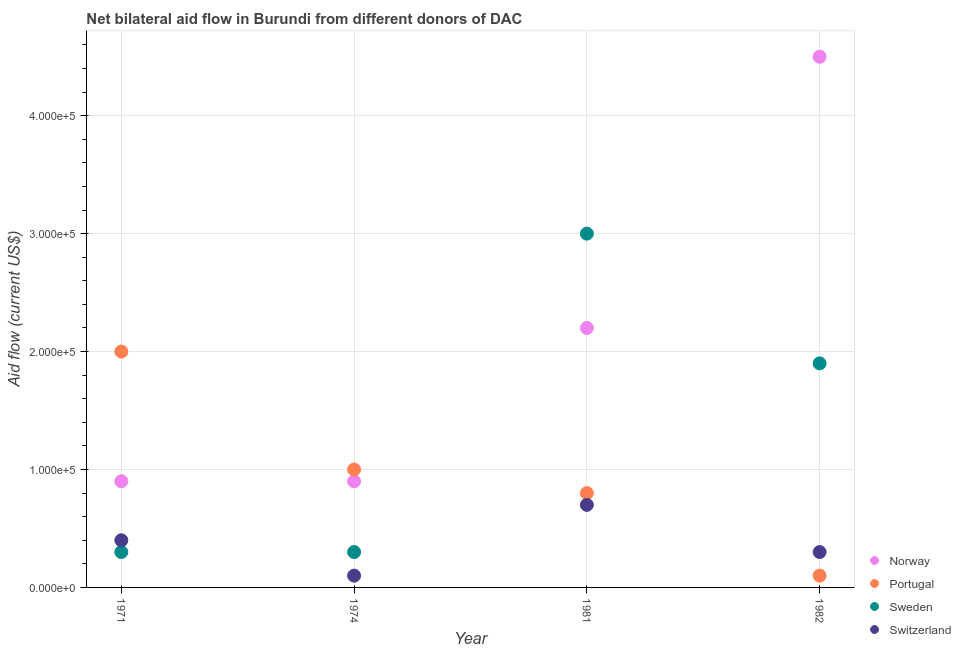How many different coloured dotlines are there?
Your answer should be compact. 4. Is the number of dotlines equal to the number of legend labels?
Offer a very short reply. Yes. What is the amount of aid given by switzerland in 1974?
Ensure brevity in your answer.  10000. Across all years, what is the maximum amount of aid given by sweden?
Make the answer very short. 3.00e+05. Across all years, what is the minimum amount of aid given by norway?
Your response must be concise. 9.00e+04. In which year was the amount of aid given by norway maximum?
Your answer should be compact. 1982. In which year was the amount of aid given by switzerland minimum?
Provide a succinct answer. 1974. What is the total amount of aid given by sweden in the graph?
Your answer should be very brief. 5.50e+05. What is the difference between the amount of aid given by switzerland in 1974 and that in 1981?
Your answer should be compact. -6.00e+04. What is the difference between the amount of aid given by switzerland in 1981 and the amount of aid given by portugal in 1971?
Keep it short and to the point. -1.30e+05. What is the average amount of aid given by switzerland per year?
Give a very brief answer. 3.75e+04. In the year 1981, what is the difference between the amount of aid given by sweden and amount of aid given by portugal?
Keep it short and to the point. 2.20e+05. What is the ratio of the amount of aid given by norway in 1974 to that in 1981?
Keep it short and to the point. 0.41. Is the difference between the amount of aid given by portugal in 1974 and 1982 greater than the difference between the amount of aid given by switzerland in 1974 and 1982?
Give a very brief answer. Yes. What is the difference between the highest and the lowest amount of aid given by portugal?
Your answer should be compact. 1.90e+05. Is the sum of the amount of aid given by sweden in 1971 and 1981 greater than the maximum amount of aid given by norway across all years?
Give a very brief answer. No. Is it the case that in every year, the sum of the amount of aid given by portugal and amount of aid given by sweden is greater than the sum of amount of aid given by switzerland and amount of aid given by norway?
Offer a very short reply. Yes. Is it the case that in every year, the sum of the amount of aid given by norway and amount of aid given by portugal is greater than the amount of aid given by sweden?
Keep it short and to the point. No. Does the amount of aid given by switzerland monotonically increase over the years?
Keep it short and to the point. No. Is the amount of aid given by switzerland strictly less than the amount of aid given by sweden over the years?
Your answer should be very brief. No. What is the difference between two consecutive major ticks on the Y-axis?
Make the answer very short. 1.00e+05. Where does the legend appear in the graph?
Provide a short and direct response. Bottom right. How many legend labels are there?
Make the answer very short. 4. How are the legend labels stacked?
Ensure brevity in your answer.  Vertical. What is the title of the graph?
Offer a terse response. Net bilateral aid flow in Burundi from different donors of DAC. Does "Methodology assessment" appear as one of the legend labels in the graph?
Provide a succinct answer. No. What is the label or title of the X-axis?
Offer a very short reply. Year. What is the label or title of the Y-axis?
Provide a succinct answer. Aid flow (current US$). What is the Aid flow (current US$) of Norway in 1974?
Your response must be concise. 9.00e+04. What is the Aid flow (current US$) of Portugal in 1974?
Your response must be concise. 1.00e+05. What is the Aid flow (current US$) of Sweden in 1974?
Offer a very short reply. 3.00e+04. What is the Aid flow (current US$) in Norway in 1981?
Provide a short and direct response. 2.20e+05. What is the Aid flow (current US$) of Portugal in 1981?
Provide a short and direct response. 8.00e+04. What is the Aid flow (current US$) of Switzerland in 1981?
Provide a succinct answer. 7.00e+04. What is the Aid flow (current US$) of Norway in 1982?
Your answer should be compact. 4.50e+05. What is the Aid flow (current US$) in Portugal in 1982?
Provide a succinct answer. 10000. What is the Aid flow (current US$) in Switzerland in 1982?
Your answer should be compact. 3.00e+04. Across all years, what is the maximum Aid flow (current US$) of Sweden?
Your response must be concise. 3.00e+05. Across all years, what is the minimum Aid flow (current US$) in Norway?
Offer a terse response. 9.00e+04. Across all years, what is the minimum Aid flow (current US$) in Sweden?
Offer a terse response. 3.00e+04. Across all years, what is the minimum Aid flow (current US$) in Switzerland?
Your answer should be compact. 10000. What is the total Aid flow (current US$) in Norway in the graph?
Offer a very short reply. 8.50e+05. What is the total Aid flow (current US$) in Sweden in the graph?
Your answer should be very brief. 5.50e+05. What is the total Aid flow (current US$) in Switzerland in the graph?
Ensure brevity in your answer.  1.50e+05. What is the difference between the Aid flow (current US$) of Sweden in 1971 and that in 1974?
Ensure brevity in your answer.  0. What is the difference between the Aid flow (current US$) of Norway in 1971 and that in 1982?
Offer a terse response. -3.60e+05. What is the difference between the Aid flow (current US$) in Switzerland in 1971 and that in 1982?
Ensure brevity in your answer.  10000. What is the difference between the Aid flow (current US$) in Portugal in 1974 and that in 1981?
Make the answer very short. 2.00e+04. What is the difference between the Aid flow (current US$) in Sweden in 1974 and that in 1981?
Offer a terse response. -2.70e+05. What is the difference between the Aid flow (current US$) in Switzerland in 1974 and that in 1981?
Your response must be concise. -6.00e+04. What is the difference between the Aid flow (current US$) in Norway in 1974 and that in 1982?
Ensure brevity in your answer.  -3.60e+05. What is the difference between the Aid flow (current US$) of Switzerland in 1974 and that in 1982?
Keep it short and to the point. -2.00e+04. What is the difference between the Aid flow (current US$) in Norway in 1981 and that in 1982?
Keep it short and to the point. -2.30e+05. What is the difference between the Aid flow (current US$) in Norway in 1971 and the Aid flow (current US$) in Portugal in 1974?
Provide a short and direct response. -10000. What is the difference between the Aid flow (current US$) of Norway in 1971 and the Aid flow (current US$) of Switzerland in 1974?
Offer a terse response. 8.00e+04. What is the difference between the Aid flow (current US$) in Portugal in 1971 and the Aid flow (current US$) in Sweden in 1974?
Offer a very short reply. 1.70e+05. What is the difference between the Aid flow (current US$) of Portugal in 1971 and the Aid flow (current US$) of Switzerland in 1974?
Keep it short and to the point. 1.90e+05. What is the difference between the Aid flow (current US$) in Norway in 1971 and the Aid flow (current US$) in Switzerland in 1981?
Give a very brief answer. 2.00e+04. What is the difference between the Aid flow (current US$) of Portugal in 1971 and the Aid flow (current US$) of Switzerland in 1981?
Give a very brief answer. 1.30e+05. What is the difference between the Aid flow (current US$) in Sweden in 1971 and the Aid flow (current US$) in Switzerland in 1981?
Your answer should be very brief. -4.00e+04. What is the difference between the Aid flow (current US$) in Norway in 1971 and the Aid flow (current US$) in Portugal in 1982?
Make the answer very short. 8.00e+04. What is the difference between the Aid flow (current US$) in Norway in 1971 and the Aid flow (current US$) in Sweden in 1982?
Keep it short and to the point. -1.00e+05. What is the difference between the Aid flow (current US$) of Norway in 1971 and the Aid flow (current US$) of Switzerland in 1982?
Your answer should be very brief. 6.00e+04. What is the difference between the Aid flow (current US$) in Portugal in 1971 and the Aid flow (current US$) in Switzerland in 1982?
Offer a terse response. 1.70e+05. What is the difference between the Aid flow (current US$) of Norway in 1974 and the Aid flow (current US$) of Portugal in 1981?
Give a very brief answer. 10000. What is the difference between the Aid flow (current US$) in Norway in 1974 and the Aid flow (current US$) in Sweden in 1981?
Make the answer very short. -2.10e+05. What is the difference between the Aid flow (current US$) in Sweden in 1974 and the Aid flow (current US$) in Switzerland in 1981?
Ensure brevity in your answer.  -4.00e+04. What is the difference between the Aid flow (current US$) in Portugal in 1974 and the Aid flow (current US$) in Sweden in 1982?
Provide a succinct answer. -9.00e+04. What is the difference between the Aid flow (current US$) in Portugal in 1974 and the Aid flow (current US$) in Switzerland in 1982?
Your answer should be very brief. 7.00e+04. What is the difference between the Aid flow (current US$) in Sweden in 1974 and the Aid flow (current US$) in Switzerland in 1982?
Give a very brief answer. 0. What is the difference between the Aid flow (current US$) of Norway in 1981 and the Aid flow (current US$) of Portugal in 1982?
Provide a succinct answer. 2.10e+05. What is the difference between the Aid flow (current US$) of Norway in 1981 and the Aid flow (current US$) of Sweden in 1982?
Your answer should be compact. 3.00e+04. What is the difference between the Aid flow (current US$) of Norway in 1981 and the Aid flow (current US$) of Switzerland in 1982?
Ensure brevity in your answer.  1.90e+05. What is the average Aid flow (current US$) in Norway per year?
Offer a very short reply. 2.12e+05. What is the average Aid flow (current US$) of Portugal per year?
Ensure brevity in your answer.  9.75e+04. What is the average Aid flow (current US$) of Sweden per year?
Offer a terse response. 1.38e+05. What is the average Aid flow (current US$) in Switzerland per year?
Offer a very short reply. 3.75e+04. In the year 1971, what is the difference between the Aid flow (current US$) of Norway and Aid flow (current US$) of Sweden?
Make the answer very short. 6.00e+04. In the year 1971, what is the difference between the Aid flow (current US$) in Norway and Aid flow (current US$) in Switzerland?
Your answer should be very brief. 5.00e+04. In the year 1974, what is the difference between the Aid flow (current US$) in Norway and Aid flow (current US$) in Portugal?
Make the answer very short. -10000. In the year 1974, what is the difference between the Aid flow (current US$) in Norway and Aid flow (current US$) in Sweden?
Provide a short and direct response. 6.00e+04. In the year 1974, what is the difference between the Aid flow (current US$) of Norway and Aid flow (current US$) of Switzerland?
Provide a short and direct response. 8.00e+04. In the year 1974, what is the difference between the Aid flow (current US$) in Portugal and Aid flow (current US$) in Sweden?
Offer a terse response. 7.00e+04. In the year 1981, what is the difference between the Aid flow (current US$) in Norway and Aid flow (current US$) in Portugal?
Offer a terse response. 1.40e+05. In the year 1981, what is the difference between the Aid flow (current US$) of Norway and Aid flow (current US$) of Switzerland?
Your response must be concise. 1.50e+05. In the year 1981, what is the difference between the Aid flow (current US$) of Sweden and Aid flow (current US$) of Switzerland?
Your answer should be compact. 2.30e+05. In the year 1982, what is the difference between the Aid flow (current US$) in Norway and Aid flow (current US$) in Portugal?
Give a very brief answer. 4.40e+05. What is the ratio of the Aid flow (current US$) in Portugal in 1971 to that in 1974?
Provide a short and direct response. 2. What is the ratio of the Aid flow (current US$) in Sweden in 1971 to that in 1974?
Provide a succinct answer. 1. What is the ratio of the Aid flow (current US$) in Switzerland in 1971 to that in 1974?
Your response must be concise. 4. What is the ratio of the Aid flow (current US$) of Norway in 1971 to that in 1981?
Offer a very short reply. 0.41. What is the ratio of the Aid flow (current US$) in Portugal in 1971 to that in 1981?
Offer a terse response. 2.5. What is the ratio of the Aid flow (current US$) in Sweden in 1971 to that in 1981?
Your answer should be compact. 0.1. What is the ratio of the Aid flow (current US$) in Sweden in 1971 to that in 1982?
Provide a short and direct response. 0.16. What is the ratio of the Aid flow (current US$) of Switzerland in 1971 to that in 1982?
Offer a very short reply. 1.33. What is the ratio of the Aid flow (current US$) in Norway in 1974 to that in 1981?
Ensure brevity in your answer.  0.41. What is the ratio of the Aid flow (current US$) in Portugal in 1974 to that in 1981?
Offer a terse response. 1.25. What is the ratio of the Aid flow (current US$) of Sweden in 1974 to that in 1981?
Make the answer very short. 0.1. What is the ratio of the Aid flow (current US$) in Switzerland in 1974 to that in 1981?
Offer a very short reply. 0.14. What is the ratio of the Aid flow (current US$) of Sweden in 1974 to that in 1982?
Provide a short and direct response. 0.16. What is the ratio of the Aid flow (current US$) of Norway in 1981 to that in 1982?
Keep it short and to the point. 0.49. What is the ratio of the Aid flow (current US$) of Sweden in 1981 to that in 1982?
Make the answer very short. 1.58. What is the ratio of the Aid flow (current US$) of Switzerland in 1981 to that in 1982?
Your answer should be compact. 2.33. What is the difference between the highest and the second highest Aid flow (current US$) of Norway?
Provide a succinct answer. 2.30e+05. What is the difference between the highest and the second highest Aid flow (current US$) of Sweden?
Give a very brief answer. 1.10e+05. What is the difference between the highest and the second highest Aid flow (current US$) of Switzerland?
Keep it short and to the point. 3.00e+04. What is the difference between the highest and the lowest Aid flow (current US$) of Portugal?
Offer a terse response. 1.90e+05. What is the difference between the highest and the lowest Aid flow (current US$) of Sweden?
Your response must be concise. 2.70e+05. What is the difference between the highest and the lowest Aid flow (current US$) in Switzerland?
Provide a short and direct response. 6.00e+04. 